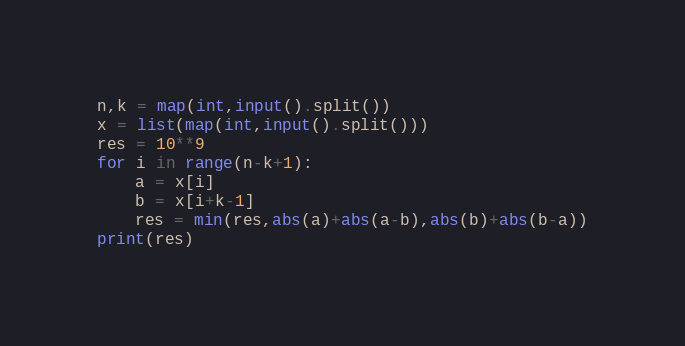<code> <loc_0><loc_0><loc_500><loc_500><_Python_>n,k = map(int,input().split())
x = list(map(int,input().split()))
res = 10**9
for i in range(n-k+1):
    a = x[i]
    b = x[i+k-1]
    res = min(res,abs(a)+abs(a-b),abs(b)+abs(b-a))
print(res)</code> 